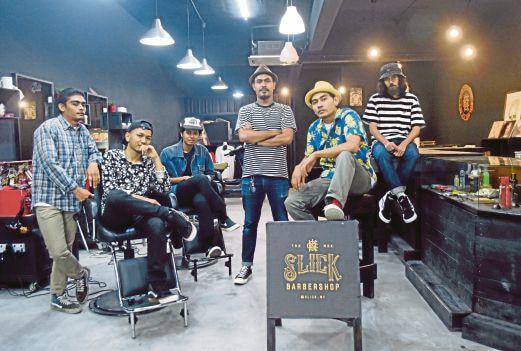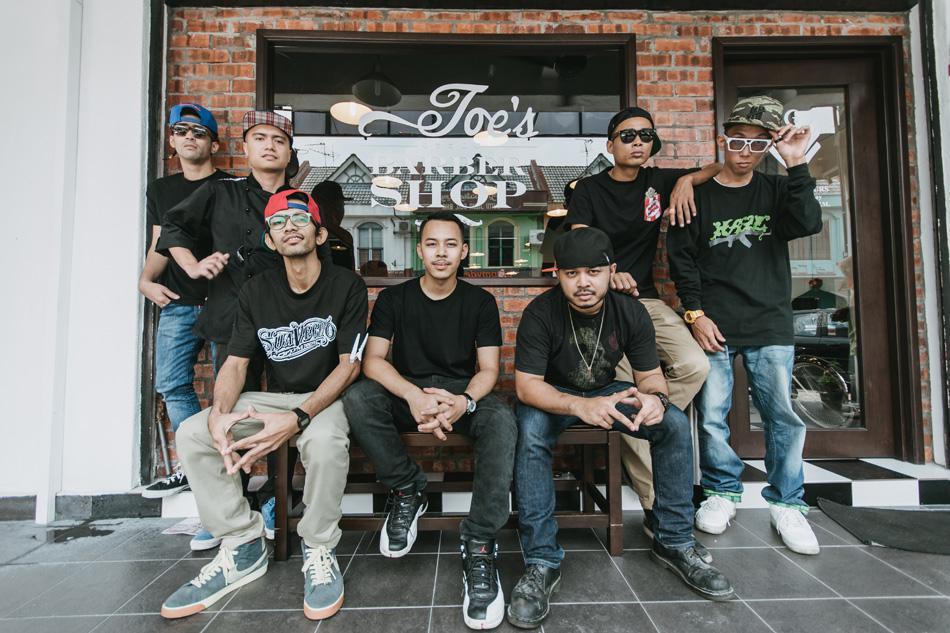The first image is the image on the left, the second image is the image on the right. Assess this claim about the two images: "One image clearly shows one barber posed with one barber chair.". Correct or not? Answer yes or no. No. The first image is the image on the left, the second image is the image on the right. Given the left and right images, does the statement "there is a door in one of the images" hold true? Answer yes or no. Yes. 